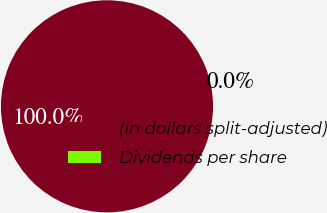Convert chart to OTSL. <chart><loc_0><loc_0><loc_500><loc_500><pie_chart><fcel>(in dollars split-adjusted)<fcel>Dividends per share<nl><fcel>100.0%<fcel>0.0%<nl></chart> 